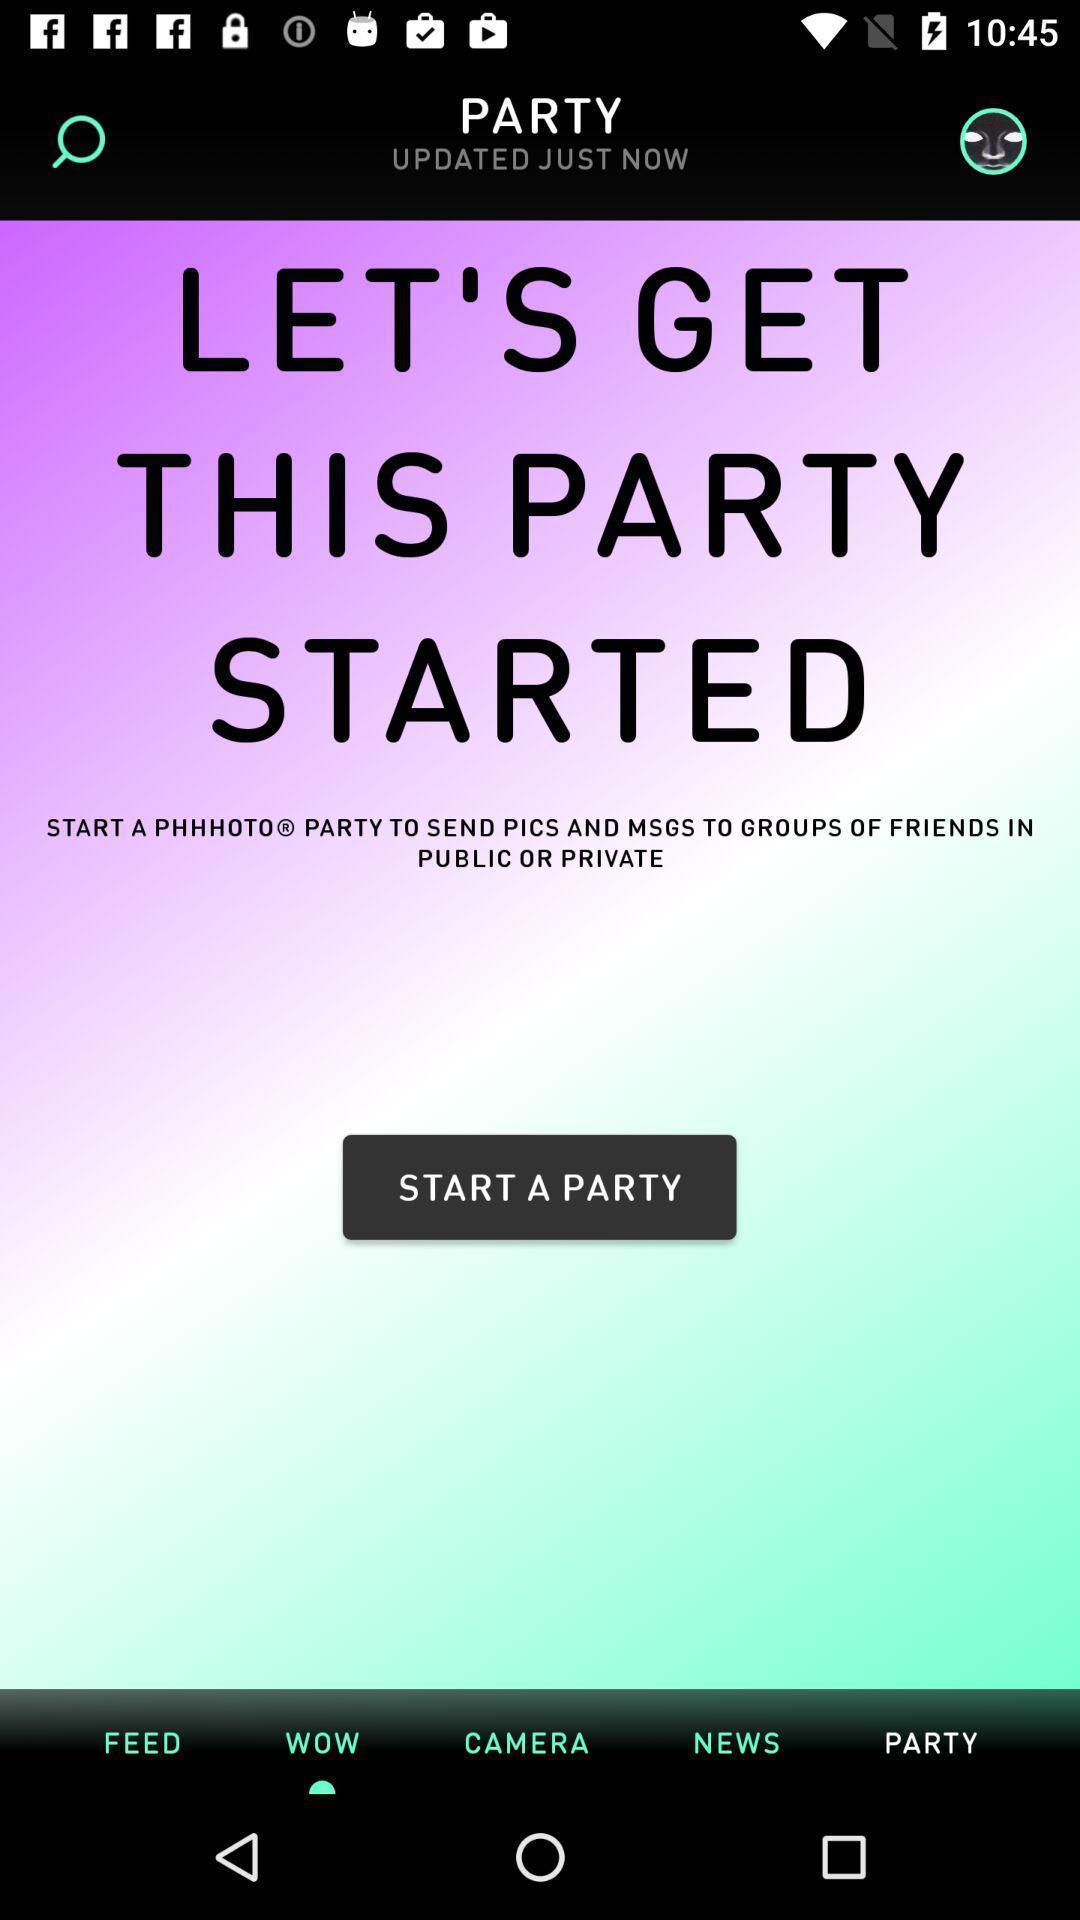What is the overall content of this screenshot? Welcome page of an entertainment app. 